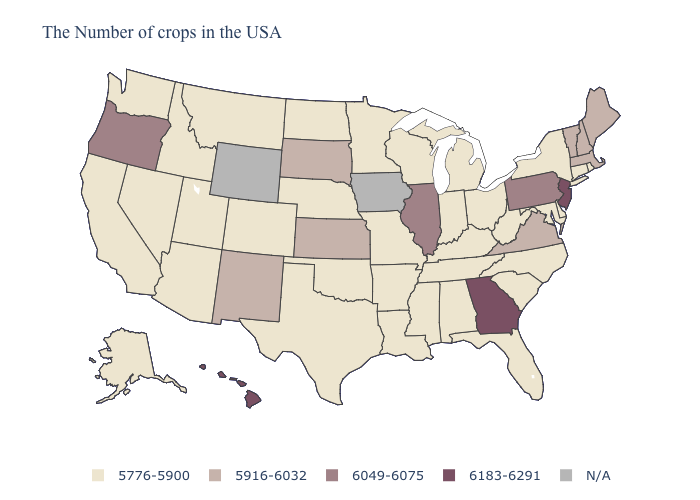What is the value of Kentucky?
Short answer required. 5776-5900. Does the map have missing data?
Write a very short answer. Yes. What is the lowest value in the USA?
Give a very brief answer. 5776-5900. What is the value of Michigan?
Be succinct. 5776-5900. Which states have the highest value in the USA?
Be succinct. New Jersey, Georgia, Hawaii. Does Alabama have the lowest value in the USA?
Quick response, please. Yes. How many symbols are there in the legend?
Keep it brief. 5. What is the highest value in states that border Missouri?
Keep it brief. 6049-6075. What is the value of Alabama?
Be succinct. 5776-5900. Name the states that have a value in the range 5916-6032?
Concise answer only. Maine, Massachusetts, New Hampshire, Vermont, Virginia, Kansas, South Dakota, New Mexico. What is the lowest value in the USA?
Be succinct. 5776-5900. What is the highest value in the USA?
Short answer required. 6183-6291. 